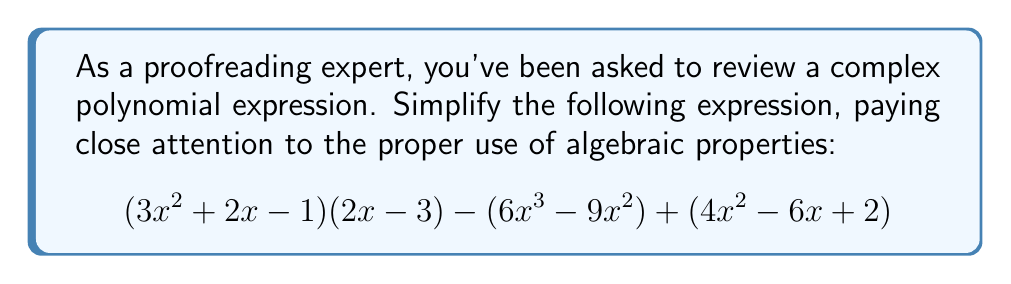Can you solve this math problem? Let's simplify this expression step-by-step:

1) First, let's expand $(3x^2 + 2x - 1)(2x - 3)$:
   $$(3x^2 + 2x - 1)(2x - 3) = 6x^3 - 9x^2 + 4x^2 - 6x - 2x + 3$$
   $$= 6x^3 - 5x^2 - 8x + 3$$

2) Now our expression looks like:
   $$(6x^3 - 5x^2 - 8x + 3) - (6x^3 - 9x^2) + (4x^2 - 6x + 2)$$

3) Let's group like terms:
   $$6x^3 - 5x^2 - 8x + 3 - 6x^3 + 9x^2 + 4x^2 - 6x + 2$$

4) Simplify:
   $$-5x^2 + 9x^2 + 4x^2 - 8x - 6x + 3 + 2$$
   $$= 8x^2 - 14x + 5$$

5) This is our simplified expression. We've combined like terms and there are no further simplifications possible.
Answer: $8x^2 - 14x + 5$ 